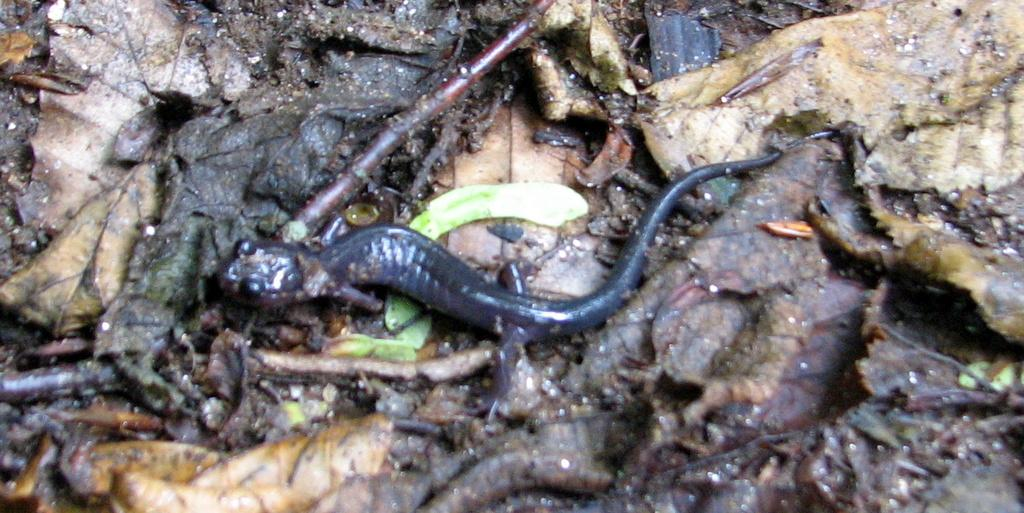What is the main subject in the center of the image? There is a snake in the center of the image. What else can be seen in the image besides the snake? There are dry leaves in the image. Can you see any bees flying around the snake in the image? There are no bees visible in the image. Is there any water present in the image? There is no water present in the image. 